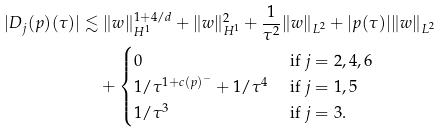Convert formula to latex. <formula><loc_0><loc_0><loc_500><loc_500>| D _ { j } ( p ) ( \tau ) | \lesssim & \ \| w \| _ { H ^ { 1 } } ^ { 1 + 4 / d } + \| w \| _ { H ^ { 1 } } ^ { 2 } + \frac { 1 } { \tau ^ { 2 } } \| w \| _ { L ^ { 2 } } + | p ( \tau ) | \| w \| _ { L ^ { 2 } } \\ & + \begin{cases} 0 & \text { if } j = 2 , 4 , 6 \\ 1 / { \tau ^ { 1 + c ( p ) ^ { - } } } + 1 / { \tau ^ { 4 } } & \text { if } j = 1 , 5 \\ 1 / { \tau ^ { 3 } } & \text { if } j = 3 . \end{cases}</formula> 